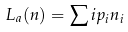<formula> <loc_0><loc_0><loc_500><loc_500>L _ { a } ( n ) = \sum i p _ { i } n _ { i }</formula> 